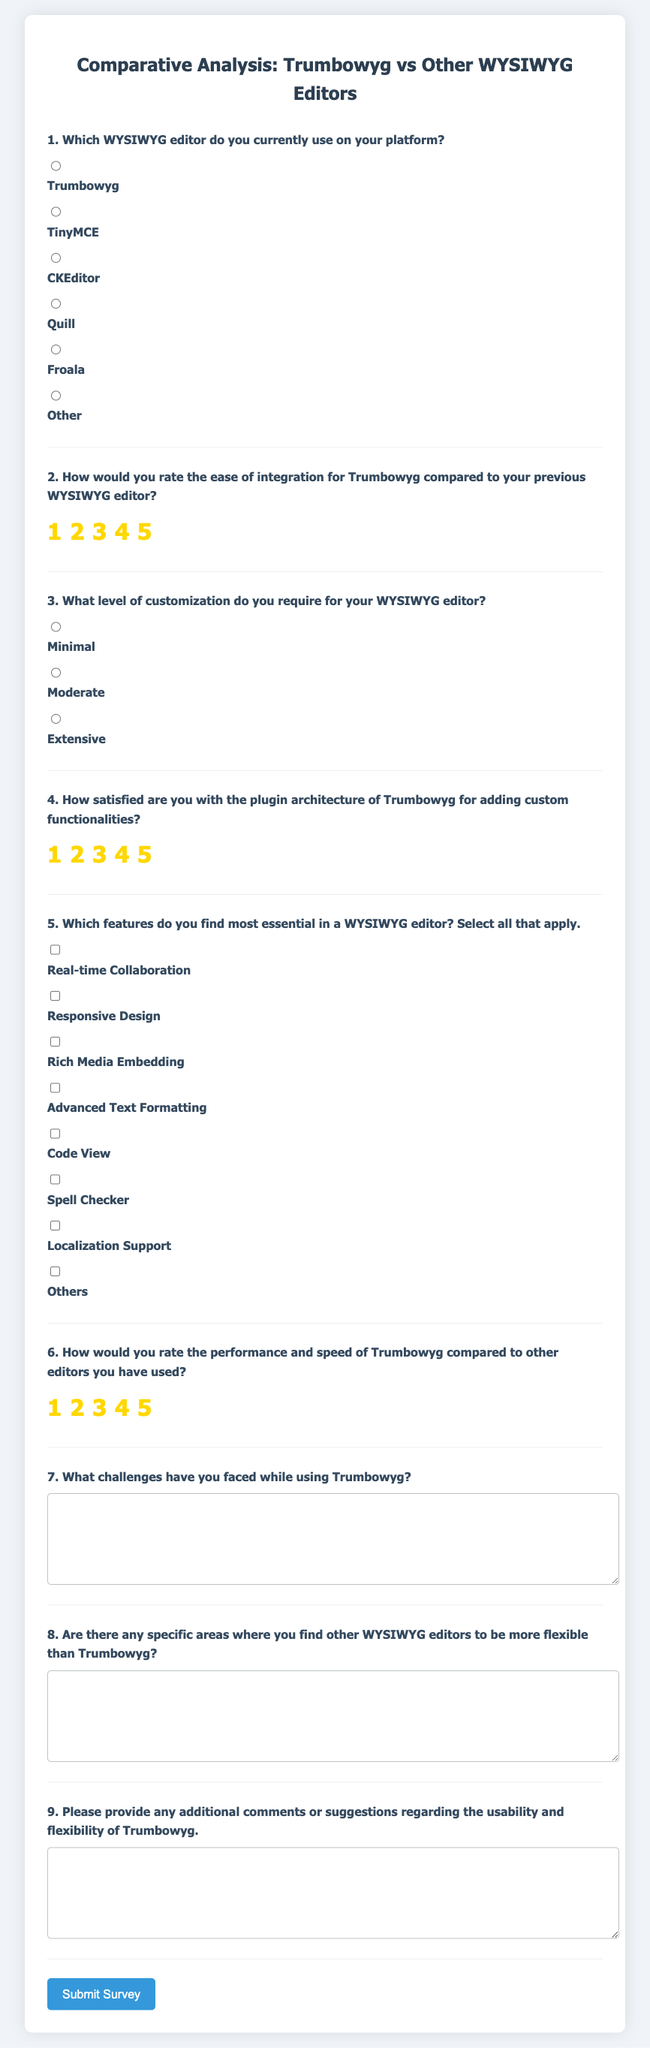What is the title of the survey? The title of the survey is displayed prominently at the top of the document.
Answer: Comparative Analysis: Trumbowyg vs Other WYSIWYG Editors How many WYSIWYG editors are listed as options in the survey? The survey includes various options for WYSIWYG editors that users might currently be using.
Answer: Six What rating scale is used to assess ease of integration for Trumbowyg? The survey provides a rating scale from 1 to 5 for participants to evaluate integration ease.
Answer: 1 to 5 What type of feedback is requested regarding challenges with Trumbowyg? The survey prompts respondents to describe their challenges in a text area, which allows for detailed responses.
Answer: Text feedback How does the survey measure satisfaction with the plugin architecture? Respondents rate their satisfaction on a scale of 1 to 5, similar to other evaluations in the survey.
Answer: 1 to 5 